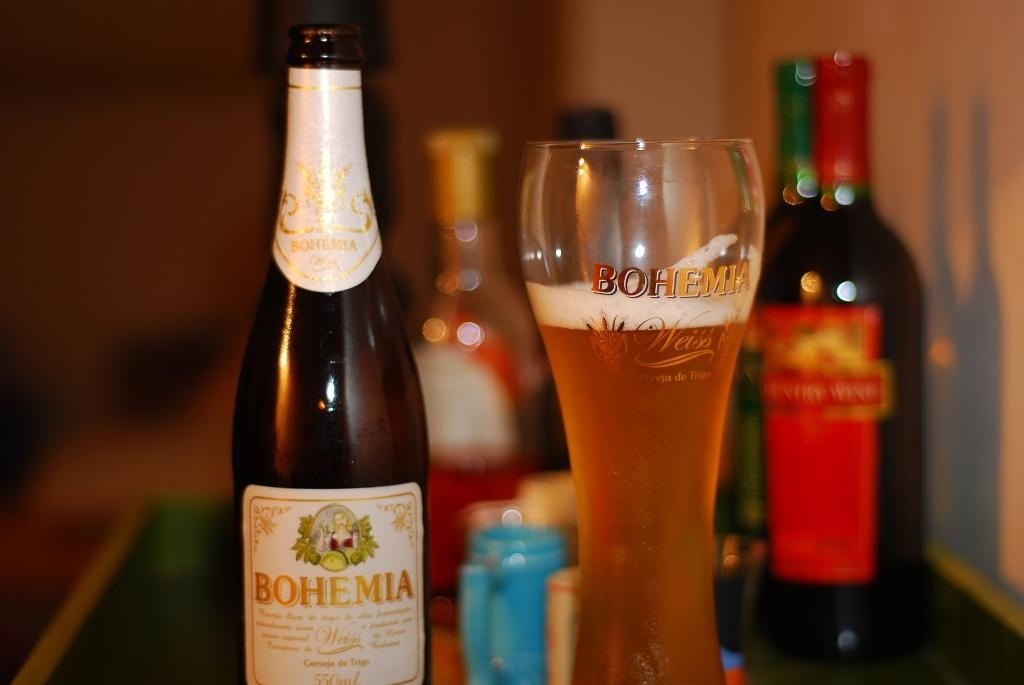<image>
Relay a brief, clear account of the picture shown. A bottle of "BOHEMIA" sits next to a glass. 